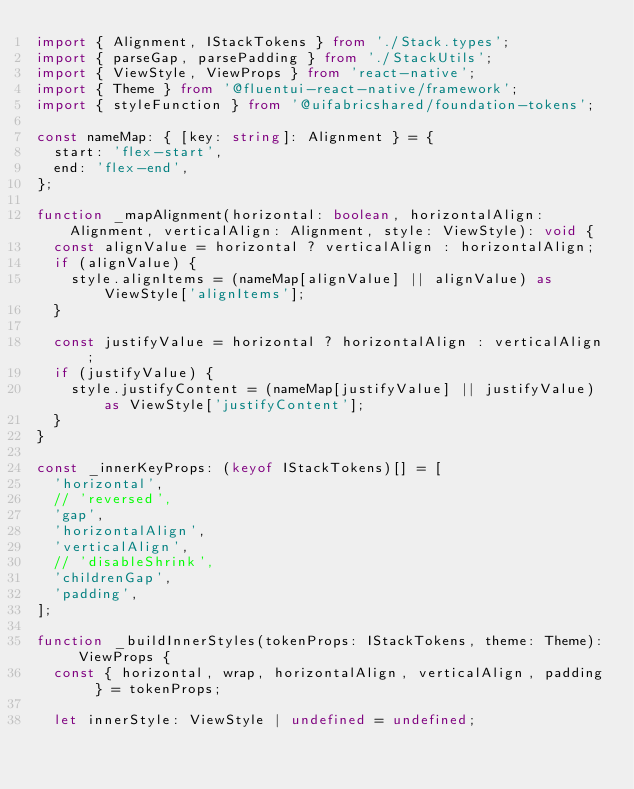Convert code to text. <code><loc_0><loc_0><loc_500><loc_500><_TypeScript_>import { Alignment, IStackTokens } from './Stack.types';
import { parseGap, parsePadding } from './StackUtils';
import { ViewStyle, ViewProps } from 'react-native';
import { Theme } from '@fluentui-react-native/framework';
import { styleFunction } from '@uifabricshared/foundation-tokens';

const nameMap: { [key: string]: Alignment } = {
  start: 'flex-start',
  end: 'flex-end',
};

function _mapAlignment(horizontal: boolean, horizontalAlign: Alignment, verticalAlign: Alignment, style: ViewStyle): void {
  const alignValue = horizontal ? verticalAlign : horizontalAlign;
  if (alignValue) {
    style.alignItems = (nameMap[alignValue] || alignValue) as ViewStyle['alignItems'];
  }

  const justifyValue = horizontal ? horizontalAlign : verticalAlign;
  if (justifyValue) {
    style.justifyContent = (nameMap[justifyValue] || justifyValue) as ViewStyle['justifyContent'];
  }
}

const _innerKeyProps: (keyof IStackTokens)[] = [
  'horizontal',
  // 'reversed',
  'gap',
  'horizontalAlign',
  'verticalAlign',
  // 'disableShrink',
  'childrenGap',
  'padding',
];

function _buildInnerStyles(tokenProps: IStackTokens, theme: Theme): ViewProps {
  const { horizontal, wrap, horizontalAlign, verticalAlign, padding } = tokenProps;

  let innerStyle: ViewStyle | undefined = undefined;</code> 